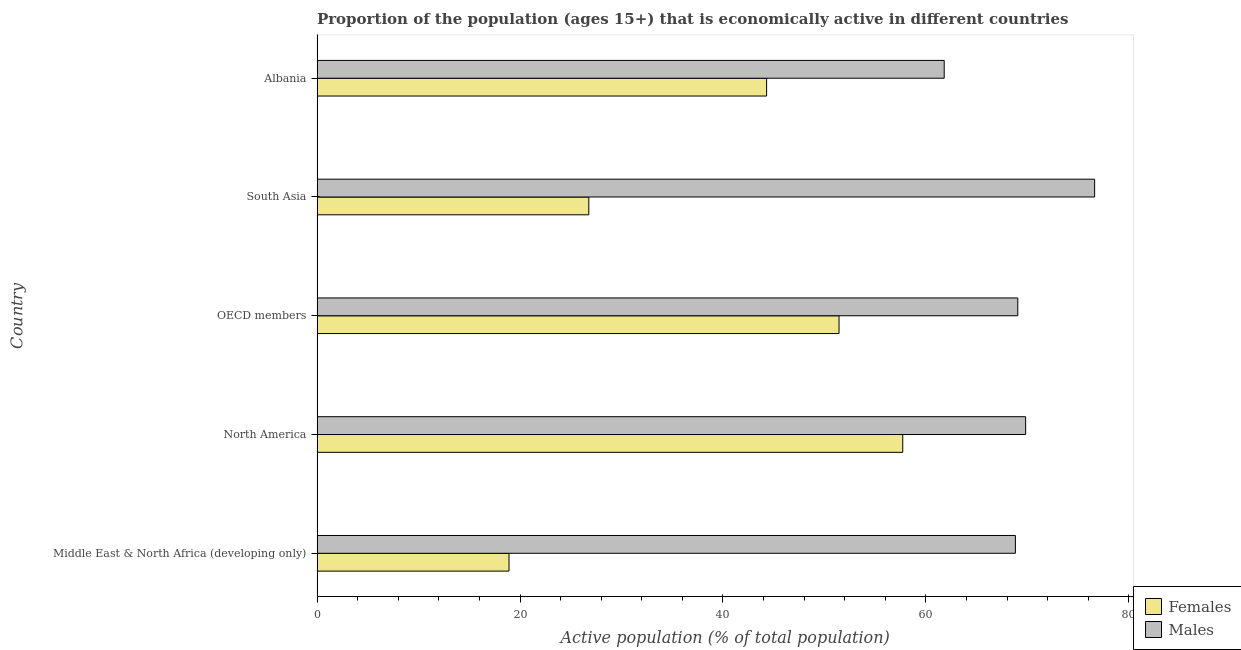How many different coloured bars are there?
Your answer should be compact. 2. Are the number of bars on each tick of the Y-axis equal?
Offer a very short reply. Yes. How many bars are there on the 3rd tick from the bottom?
Your answer should be very brief. 2. What is the label of the 1st group of bars from the top?
Offer a terse response. Albania. In how many cases, is the number of bars for a given country not equal to the number of legend labels?
Provide a succinct answer. 0. What is the percentage of economically active female population in North America?
Your response must be concise. 57.72. Across all countries, what is the maximum percentage of economically active female population?
Offer a very short reply. 57.72. Across all countries, what is the minimum percentage of economically active male population?
Provide a succinct answer. 61.8. In which country was the percentage of economically active female population minimum?
Provide a short and direct response. Middle East & North Africa (developing only). What is the total percentage of economically active male population in the graph?
Your answer should be very brief. 346.11. What is the difference between the percentage of economically active female population in North America and that in South Asia?
Make the answer very short. 30.94. What is the difference between the percentage of economically active male population in South Asia and the percentage of economically active female population in Albania?
Make the answer very short. 32.32. What is the average percentage of economically active male population per country?
Your response must be concise. 69.22. What is the difference between the percentage of economically active female population and percentage of economically active male population in South Asia?
Your answer should be compact. -49.84. What is the ratio of the percentage of economically active female population in Middle East & North Africa (developing only) to that in South Asia?
Make the answer very short. 0.71. Is the percentage of economically active female population in Albania less than that in OECD members?
Make the answer very short. Yes. Is the difference between the percentage of economically active male population in Albania and OECD members greater than the difference between the percentage of economically active female population in Albania and OECD members?
Keep it short and to the point. No. What is the difference between the highest and the second highest percentage of economically active male population?
Offer a terse response. 6.8. What is the difference between the highest and the lowest percentage of economically active male population?
Your response must be concise. 14.82. In how many countries, is the percentage of economically active female population greater than the average percentage of economically active female population taken over all countries?
Your answer should be compact. 3. Is the sum of the percentage of economically active male population in Middle East & North Africa (developing only) and OECD members greater than the maximum percentage of economically active female population across all countries?
Provide a short and direct response. Yes. What does the 2nd bar from the top in North America represents?
Your answer should be very brief. Females. What does the 2nd bar from the bottom in Albania represents?
Make the answer very short. Males. How many bars are there?
Ensure brevity in your answer.  10. How many countries are there in the graph?
Keep it short and to the point. 5. What is the difference between two consecutive major ticks on the X-axis?
Provide a succinct answer. 20. Where does the legend appear in the graph?
Ensure brevity in your answer.  Bottom right. How many legend labels are there?
Keep it short and to the point. 2. How are the legend labels stacked?
Your answer should be very brief. Vertical. What is the title of the graph?
Provide a short and direct response. Proportion of the population (ages 15+) that is economically active in different countries. Does "Agricultural land" appear as one of the legend labels in the graph?
Your answer should be compact. No. What is the label or title of the X-axis?
Offer a terse response. Active population (% of total population). What is the Active population (% of total population) of Females in Middle East & North Africa (developing only)?
Ensure brevity in your answer.  18.91. What is the Active population (% of total population) in Males in Middle East & North Africa (developing only)?
Make the answer very short. 68.81. What is the Active population (% of total population) in Females in North America?
Ensure brevity in your answer.  57.72. What is the Active population (% of total population) in Males in North America?
Ensure brevity in your answer.  69.82. What is the Active population (% of total population) of Females in OECD members?
Keep it short and to the point. 51.44. What is the Active population (% of total population) in Males in OECD members?
Your answer should be compact. 69.05. What is the Active population (% of total population) in Females in South Asia?
Your answer should be very brief. 26.78. What is the Active population (% of total population) in Males in South Asia?
Your answer should be compact. 76.62. What is the Active population (% of total population) in Females in Albania?
Provide a succinct answer. 44.3. What is the Active population (% of total population) in Males in Albania?
Ensure brevity in your answer.  61.8. Across all countries, what is the maximum Active population (% of total population) of Females?
Keep it short and to the point. 57.72. Across all countries, what is the maximum Active population (% of total population) in Males?
Offer a very short reply. 76.62. Across all countries, what is the minimum Active population (% of total population) in Females?
Keep it short and to the point. 18.91. Across all countries, what is the minimum Active population (% of total population) in Males?
Your answer should be compact. 61.8. What is the total Active population (% of total population) in Females in the graph?
Offer a very short reply. 199.14. What is the total Active population (% of total population) of Males in the graph?
Give a very brief answer. 346.11. What is the difference between the Active population (% of total population) in Females in Middle East & North Africa (developing only) and that in North America?
Give a very brief answer. -38.8. What is the difference between the Active population (% of total population) of Males in Middle East & North Africa (developing only) and that in North America?
Make the answer very short. -1.01. What is the difference between the Active population (% of total population) in Females in Middle East & North Africa (developing only) and that in OECD members?
Keep it short and to the point. -32.52. What is the difference between the Active population (% of total population) of Males in Middle East & North Africa (developing only) and that in OECD members?
Ensure brevity in your answer.  -0.24. What is the difference between the Active population (% of total population) of Females in Middle East & North Africa (developing only) and that in South Asia?
Provide a succinct answer. -7.86. What is the difference between the Active population (% of total population) of Males in Middle East & North Africa (developing only) and that in South Asia?
Your answer should be very brief. -7.81. What is the difference between the Active population (% of total population) of Females in Middle East & North Africa (developing only) and that in Albania?
Give a very brief answer. -25.39. What is the difference between the Active population (% of total population) in Males in Middle East & North Africa (developing only) and that in Albania?
Provide a succinct answer. 7.01. What is the difference between the Active population (% of total population) in Females in North America and that in OECD members?
Keep it short and to the point. 6.28. What is the difference between the Active population (% of total population) in Males in North America and that in OECD members?
Provide a succinct answer. 0.77. What is the difference between the Active population (% of total population) in Females in North America and that in South Asia?
Your answer should be compact. 30.94. What is the difference between the Active population (% of total population) in Males in North America and that in South Asia?
Ensure brevity in your answer.  -6.8. What is the difference between the Active population (% of total population) in Females in North America and that in Albania?
Keep it short and to the point. 13.42. What is the difference between the Active population (% of total population) of Males in North America and that in Albania?
Keep it short and to the point. 8.02. What is the difference between the Active population (% of total population) in Females in OECD members and that in South Asia?
Make the answer very short. 24.66. What is the difference between the Active population (% of total population) of Males in OECD members and that in South Asia?
Your response must be concise. -7.57. What is the difference between the Active population (% of total population) of Females in OECD members and that in Albania?
Your response must be concise. 7.14. What is the difference between the Active population (% of total population) in Males in OECD members and that in Albania?
Provide a short and direct response. 7.25. What is the difference between the Active population (% of total population) in Females in South Asia and that in Albania?
Give a very brief answer. -17.52. What is the difference between the Active population (% of total population) in Males in South Asia and that in Albania?
Provide a short and direct response. 14.82. What is the difference between the Active population (% of total population) of Females in Middle East & North Africa (developing only) and the Active population (% of total population) of Males in North America?
Make the answer very short. -50.91. What is the difference between the Active population (% of total population) in Females in Middle East & North Africa (developing only) and the Active population (% of total population) in Males in OECD members?
Keep it short and to the point. -50.14. What is the difference between the Active population (% of total population) of Females in Middle East & North Africa (developing only) and the Active population (% of total population) of Males in South Asia?
Your answer should be compact. -57.71. What is the difference between the Active population (% of total population) of Females in Middle East & North Africa (developing only) and the Active population (% of total population) of Males in Albania?
Keep it short and to the point. -42.89. What is the difference between the Active population (% of total population) in Females in North America and the Active population (% of total population) in Males in OECD members?
Make the answer very short. -11.34. What is the difference between the Active population (% of total population) in Females in North America and the Active population (% of total population) in Males in South Asia?
Your answer should be very brief. -18.91. What is the difference between the Active population (% of total population) of Females in North America and the Active population (% of total population) of Males in Albania?
Offer a very short reply. -4.08. What is the difference between the Active population (% of total population) of Females in OECD members and the Active population (% of total population) of Males in South Asia?
Offer a terse response. -25.19. What is the difference between the Active population (% of total population) of Females in OECD members and the Active population (% of total population) of Males in Albania?
Offer a terse response. -10.36. What is the difference between the Active population (% of total population) in Females in South Asia and the Active population (% of total population) in Males in Albania?
Your response must be concise. -35.02. What is the average Active population (% of total population) in Females per country?
Offer a very short reply. 39.83. What is the average Active population (% of total population) in Males per country?
Your answer should be very brief. 69.22. What is the difference between the Active population (% of total population) in Females and Active population (% of total population) in Males in Middle East & North Africa (developing only)?
Provide a succinct answer. -49.9. What is the difference between the Active population (% of total population) of Females and Active population (% of total population) of Males in North America?
Your answer should be very brief. -12.11. What is the difference between the Active population (% of total population) in Females and Active population (% of total population) in Males in OECD members?
Your answer should be compact. -17.61. What is the difference between the Active population (% of total population) of Females and Active population (% of total population) of Males in South Asia?
Give a very brief answer. -49.85. What is the difference between the Active population (% of total population) of Females and Active population (% of total population) of Males in Albania?
Give a very brief answer. -17.5. What is the ratio of the Active population (% of total population) in Females in Middle East & North Africa (developing only) to that in North America?
Your response must be concise. 0.33. What is the ratio of the Active population (% of total population) in Males in Middle East & North Africa (developing only) to that in North America?
Keep it short and to the point. 0.99. What is the ratio of the Active population (% of total population) in Females in Middle East & North Africa (developing only) to that in OECD members?
Your answer should be compact. 0.37. What is the ratio of the Active population (% of total population) in Females in Middle East & North Africa (developing only) to that in South Asia?
Ensure brevity in your answer.  0.71. What is the ratio of the Active population (% of total population) in Males in Middle East & North Africa (developing only) to that in South Asia?
Offer a terse response. 0.9. What is the ratio of the Active population (% of total population) of Females in Middle East & North Africa (developing only) to that in Albania?
Offer a very short reply. 0.43. What is the ratio of the Active population (% of total population) in Males in Middle East & North Africa (developing only) to that in Albania?
Offer a terse response. 1.11. What is the ratio of the Active population (% of total population) of Females in North America to that in OECD members?
Make the answer very short. 1.12. What is the ratio of the Active population (% of total population) in Males in North America to that in OECD members?
Provide a short and direct response. 1.01. What is the ratio of the Active population (% of total population) of Females in North America to that in South Asia?
Your response must be concise. 2.16. What is the ratio of the Active population (% of total population) in Males in North America to that in South Asia?
Make the answer very short. 0.91. What is the ratio of the Active population (% of total population) of Females in North America to that in Albania?
Keep it short and to the point. 1.3. What is the ratio of the Active population (% of total population) in Males in North America to that in Albania?
Provide a short and direct response. 1.13. What is the ratio of the Active population (% of total population) in Females in OECD members to that in South Asia?
Your answer should be compact. 1.92. What is the ratio of the Active population (% of total population) of Males in OECD members to that in South Asia?
Offer a terse response. 0.9. What is the ratio of the Active population (% of total population) of Females in OECD members to that in Albania?
Offer a terse response. 1.16. What is the ratio of the Active population (% of total population) in Males in OECD members to that in Albania?
Provide a short and direct response. 1.12. What is the ratio of the Active population (% of total population) in Females in South Asia to that in Albania?
Offer a very short reply. 0.6. What is the ratio of the Active population (% of total population) in Males in South Asia to that in Albania?
Give a very brief answer. 1.24. What is the difference between the highest and the second highest Active population (% of total population) of Females?
Your answer should be compact. 6.28. What is the difference between the highest and the second highest Active population (% of total population) in Males?
Offer a very short reply. 6.8. What is the difference between the highest and the lowest Active population (% of total population) of Females?
Provide a short and direct response. 38.8. What is the difference between the highest and the lowest Active population (% of total population) of Males?
Provide a succinct answer. 14.82. 